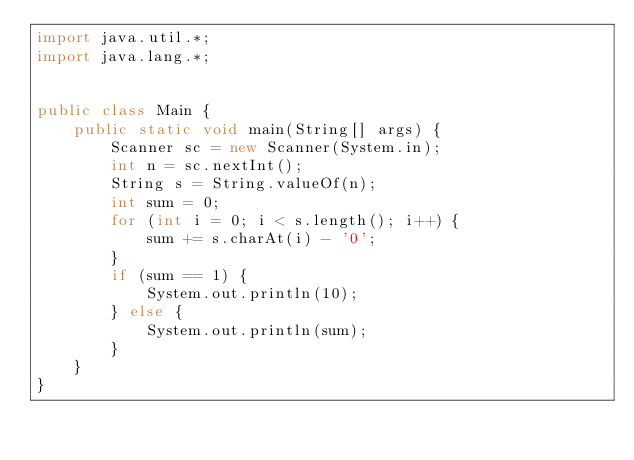Convert code to text. <code><loc_0><loc_0><loc_500><loc_500><_Java_>import java.util.*;
import java.lang.*;


public class Main {
    public static void main(String[] args) {
        Scanner sc = new Scanner(System.in);
        int n = sc.nextInt();
        String s = String.valueOf(n);
        int sum = 0;
        for (int i = 0; i < s.length(); i++) {
            sum += s.charAt(i) - '0';
        }
        if (sum == 1) {
            System.out.println(10);
        } else {
            System.out.println(sum);
        }
    }
}</code> 